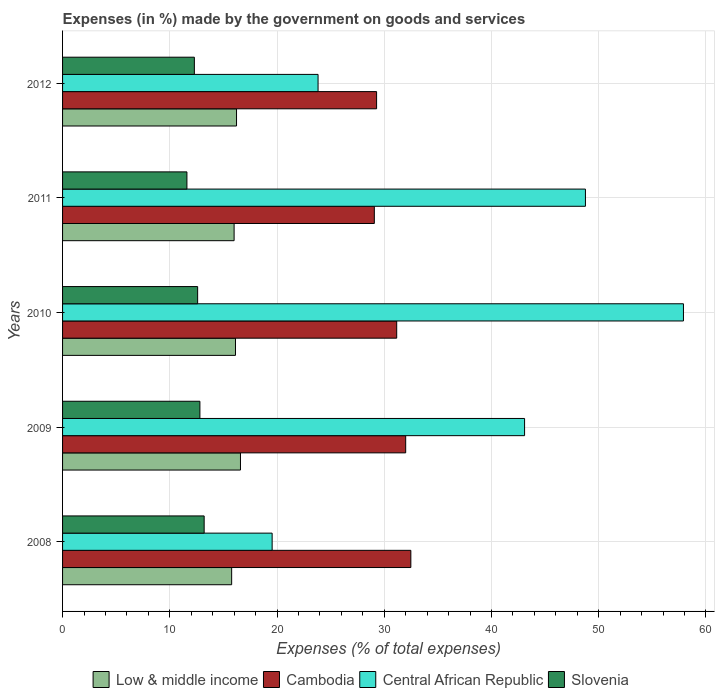How many groups of bars are there?
Offer a terse response. 5. Are the number of bars per tick equal to the number of legend labels?
Your answer should be compact. Yes. Are the number of bars on each tick of the Y-axis equal?
Your answer should be very brief. Yes. How many bars are there on the 4th tick from the top?
Keep it short and to the point. 4. What is the percentage of expenses made by the government on goods and services in Cambodia in 2008?
Give a very brief answer. 32.48. Across all years, what is the maximum percentage of expenses made by the government on goods and services in Cambodia?
Offer a terse response. 32.48. Across all years, what is the minimum percentage of expenses made by the government on goods and services in Low & middle income?
Provide a succinct answer. 15.77. In which year was the percentage of expenses made by the government on goods and services in Low & middle income minimum?
Your response must be concise. 2008. What is the total percentage of expenses made by the government on goods and services in Central African Republic in the graph?
Offer a very short reply. 193.13. What is the difference between the percentage of expenses made by the government on goods and services in Central African Republic in 2010 and that in 2011?
Offer a very short reply. 9.14. What is the difference between the percentage of expenses made by the government on goods and services in Central African Republic in 2011 and the percentage of expenses made by the government on goods and services in Slovenia in 2012?
Keep it short and to the point. 36.47. What is the average percentage of expenses made by the government on goods and services in Cambodia per year?
Your answer should be very brief. 30.8. In the year 2011, what is the difference between the percentage of expenses made by the government on goods and services in Cambodia and percentage of expenses made by the government on goods and services in Slovenia?
Offer a terse response. 17.48. In how many years, is the percentage of expenses made by the government on goods and services in Slovenia greater than 8 %?
Your answer should be compact. 5. What is the ratio of the percentage of expenses made by the government on goods and services in Cambodia in 2009 to that in 2011?
Provide a short and direct response. 1.1. Is the percentage of expenses made by the government on goods and services in Low & middle income in 2008 less than that in 2011?
Offer a terse response. Yes. What is the difference between the highest and the second highest percentage of expenses made by the government on goods and services in Central African Republic?
Offer a very short reply. 9.14. What is the difference between the highest and the lowest percentage of expenses made by the government on goods and services in Central African Republic?
Provide a succinct answer. 38.36. Is it the case that in every year, the sum of the percentage of expenses made by the government on goods and services in Slovenia and percentage of expenses made by the government on goods and services in Cambodia is greater than the sum of percentage of expenses made by the government on goods and services in Central African Republic and percentage of expenses made by the government on goods and services in Low & middle income?
Your response must be concise. Yes. What does the 1st bar from the top in 2012 represents?
Offer a very short reply. Slovenia. What does the 4th bar from the bottom in 2012 represents?
Your answer should be compact. Slovenia. Is it the case that in every year, the sum of the percentage of expenses made by the government on goods and services in Low & middle income and percentage of expenses made by the government on goods and services in Slovenia is greater than the percentage of expenses made by the government on goods and services in Cambodia?
Your response must be concise. No. What is the difference between two consecutive major ticks on the X-axis?
Your response must be concise. 10. Are the values on the major ticks of X-axis written in scientific E-notation?
Give a very brief answer. No. Where does the legend appear in the graph?
Keep it short and to the point. Bottom center. How many legend labels are there?
Provide a succinct answer. 4. What is the title of the graph?
Your answer should be very brief. Expenses (in %) made by the government on goods and services. Does "Greenland" appear as one of the legend labels in the graph?
Offer a very short reply. No. What is the label or title of the X-axis?
Keep it short and to the point. Expenses (% of total expenses). What is the label or title of the Y-axis?
Provide a short and direct response. Years. What is the Expenses (% of total expenses) in Low & middle income in 2008?
Your answer should be compact. 15.77. What is the Expenses (% of total expenses) in Cambodia in 2008?
Keep it short and to the point. 32.48. What is the Expenses (% of total expenses) of Central African Republic in 2008?
Keep it short and to the point. 19.55. What is the Expenses (% of total expenses) in Slovenia in 2008?
Your answer should be very brief. 13.21. What is the Expenses (% of total expenses) in Low & middle income in 2009?
Provide a short and direct response. 16.59. What is the Expenses (% of total expenses) in Cambodia in 2009?
Give a very brief answer. 32. What is the Expenses (% of total expenses) of Central African Republic in 2009?
Your response must be concise. 43.09. What is the Expenses (% of total expenses) in Slovenia in 2009?
Provide a succinct answer. 12.81. What is the Expenses (% of total expenses) of Low & middle income in 2010?
Your answer should be compact. 16.13. What is the Expenses (% of total expenses) in Cambodia in 2010?
Offer a very short reply. 31.16. What is the Expenses (% of total expenses) of Central African Republic in 2010?
Provide a succinct answer. 57.91. What is the Expenses (% of total expenses) of Slovenia in 2010?
Your response must be concise. 12.6. What is the Expenses (% of total expenses) of Low & middle income in 2011?
Make the answer very short. 16. What is the Expenses (% of total expenses) in Cambodia in 2011?
Provide a short and direct response. 29.08. What is the Expenses (% of total expenses) in Central African Republic in 2011?
Provide a short and direct response. 48.76. What is the Expenses (% of total expenses) in Slovenia in 2011?
Provide a succinct answer. 11.6. What is the Expenses (% of total expenses) in Low & middle income in 2012?
Your answer should be very brief. 16.22. What is the Expenses (% of total expenses) in Cambodia in 2012?
Offer a terse response. 29.29. What is the Expenses (% of total expenses) of Central African Republic in 2012?
Offer a very short reply. 23.83. What is the Expenses (% of total expenses) of Slovenia in 2012?
Offer a terse response. 12.29. Across all years, what is the maximum Expenses (% of total expenses) of Low & middle income?
Provide a succinct answer. 16.59. Across all years, what is the maximum Expenses (% of total expenses) in Cambodia?
Your answer should be very brief. 32.48. Across all years, what is the maximum Expenses (% of total expenses) in Central African Republic?
Your answer should be compact. 57.91. Across all years, what is the maximum Expenses (% of total expenses) of Slovenia?
Your answer should be compact. 13.21. Across all years, what is the minimum Expenses (% of total expenses) in Low & middle income?
Keep it short and to the point. 15.77. Across all years, what is the minimum Expenses (% of total expenses) in Cambodia?
Keep it short and to the point. 29.08. Across all years, what is the minimum Expenses (% of total expenses) of Central African Republic?
Make the answer very short. 19.55. Across all years, what is the minimum Expenses (% of total expenses) of Slovenia?
Make the answer very short. 11.6. What is the total Expenses (% of total expenses) in Low & middle income in the graph?
Provide a succinct answer. 80.71. What is the total Expenses (% of total expenses) of Cambodia in the graph?
Your answer should be very brief. 154.01. What is the total Expenses (% of total expenses) in Central African Republic in the graph?
Provide a succinct answer. 193.13. What is the total Expenses (% of total expenses) in Slovenia in the graph?
Keep it short and to the point. 62.5. What is the difference between the Expenses (% of total expenses) of Low & middle income in 2008 and that in 2009?
Keep it short and to the point. -0.82. What is the difference between the Expenses (% of total expenses) in Cambodia in 2008 and that in 2009?
Make the answer very short. 0.48. What is the difference between the Expenses (% of total expenses) of Central African Republic in 2008 and that in 2009?
Your answer should be compact. -23.54. What is the difference between the Expenses (% of total expenses) of Slovenia in 2008 and that in 2009?
Offer a terse response. 0.4. What is the difference between the Expenses (% of total expenses) in Low & middle income in 2008 and that in 2010?
Offer a very short reply. -0.36. What is the difference between the Expenses (% of total expenses) of Cambodia in 2008 and that in 2010?
Keep it short and to the point. 1.32. What is the difference between the Expenses (% of total expenses) in Central African Republic in 2008 and that in 2010?
Provide a short and direct response. -38.36. What is the difference between the Expenses (% of total expenses) of Slovenia in 2008 and that in 2010?
Your answer should be very brief. 0.61. What is the difference between the Expenses (% of total expenses) of Low & middle income in 2008 and that in 2011?
Offer a terse response. -0.23. What is the difference between the Expenses (% of total expenses) in Cambodia in 2008 and that in 2011?
Provide a short and direct response. 3.41. What is the difference between the Expenses (% of total expenses) of Central African Republic in 2008 and that in 2011?
Ensure brevity in your answer.  -29.22. What is the difference between the Expenses (% of total expenses) in Slovenia in 2008 and that in 2011?
Give a very brief answer. 1.61. What is the difference between the Expenses (% of total expenses) in Low & middle income in 2008 and that in 2012?
Ensure brevity in your answer.  -0.45. What is the difference between the Expenses (% of total expenses) in Cambodia in 2008 and that in 2012?
Give a very brief answer. 3.2. What is the difference between the Expenses (% of total expenses) in Central African Republic in 2008 and that in 2012?
Offer a terse response. -4.28. What is the difference between the Expenses (% of total expenses) in Slovenia in 2008 and that in 2012?
Offer a very short reply. 0.91. What is the difference between the Expenses (% of total expenses) of Low & middle income in 2009 and that in 2010?
Give a very brief answer. 0.46. What is the difference between the Expenses (% of total expenses) of Cambodia in 2009 and that in 2010?
Offer a terse response. 0.84. What is the difference between the Expenses (% of total expenses) in Central African Republic in 2009 and that in 2010?
Your answer should be very brief. -14.82. What is the difference between the Expenses (% of total expenses) in Slovenia in 2009 and that in 2010?
Make the answer very short. 0.21. What is the difference between the Expenses (% of total expenses) in Low & middle income in 2009 and that in 2011?
Your answer should be compact. 0.59. What is the difference between the Expenses (% of total expenses) of Cambodia in 2009 and that in 2011?
Your answer should be very brief. 2.92. What is the difference between the Expenses (% of total expenses) in Central African Republic in 2009 and that in 2011?
Your response must be concise. -5.68. What is the difference between the Expenses (% of total expenses) in Slovenia in 2009 and that in 2011?
Make the answer very short. 1.21. What is the difference between the Expenses (% of total expenses) of Low & middle income in 2009 and that in 2012?
Your response must be concise. 0.37. What is the difference between the Expenses (% of total expenses) of Cambodia in 2009 and that in 2012?
Keep it short and to the point. 2.71. What is the difference between the Expenses (% of total expenses) in Central African Republic in 2009 and that in 2012?
Offer a very short reply. 19.26. What is the difference between the Expenses (% of total expenses) of Slovenia in 2009 and that in 2012?
Your answer should be compact. 0.52. What is the difference between the Expenses (% of total expenses) in Low & middle income in 2010 and that in 2011?
Offer a very short reply. 0.13. What is the difference between the Expenses (% of total expenses) in Cambodia in 2010 and that in 2011?
Keep it short and to the point. 2.09. What is the difference between the Expenses (% of total expenses) of Central African Republic in 2010 and that in 2011?
Give a very brief answer. 9.14. What is the difference between the Expenses (% of total expenses) of Low & middle income in 2010 and that in 2012?
Provide a short and direct response. -0.1. What is the difference between the Expenses (% of total expenses) of Cambodia in 2010 and that in 2012?
Provide a short and direct response. 1.88. What is the difference between the Expenses (% of total expenses) in Central African Republic in 2010 and that in 2012?
Give a very brief answer. 34.08. What is the difference between the Expenses (% of total expenses) in Slovenia in 2010 and that in 2012?
Offer a very short reply. 0.31. What is the difference between the Expenses (% of total expenses) in Low & middle income in 2011 and that in 2012?
Your answer should be compact. -0.23. What is the difference between the Expenses (% of total expenses) of Cambodia in 2011 and that in 2012?
Offer a very short reply. -0.21. What is the difference between the Expenses (% of total expenses) in Central African Republic in 2011 and that in 2012?
Your response must be concise. 24.94. What is the difference between the Expenses (% of total expenses) in Slovenia in 2011 and that in 2012?
Your answer should be compact. -0.69. What is the difference between the Expenses (% of total expenses) of Low & middle income in 2008 and the Expenses (% of total expenses) of Cambodia in 2009?
Offer a very short reply. -16.23. What is the difference between the Expenses (% of total expenses) of Low & middle income in 2008 and the Expenses (% of total expenses) of Central African Republic in 2009?
Keep it short and to the point. -27.32. What is the difference between the Expenses (% of total expenses) in Low & middle income in 2008 and the Expenses (% of total expenses) in Slovenia in 2009?
Give a very brief answer. 2.96. What is the difference between the Expenses (% of total expenses) in Cambodia in 2008 and the Expenses (% of total expenses) in Central African Republic in 2009?
Offer a very short reply. -10.61. What is the difference between the Expenses (% of total expenses) of Cambodia in 2008 and the Expenses (% of total expenses) of Slovenia in 2009?
Give a very brief answer. 19.67. What is the difference between the Expenses (% of total expenses) of Central African Republic in 2008 and the Expenses (% of total expenses) of Slovenia in 2009?
Give a very brief answer. 6.74. What is the difference between the Expenses (% of total expenses) of Low & middle income in 2008 and the Expenses (% of total expenses) of Cambodia in 2010?
Keep it short and to the point. -15.39. What is the difference between the Expenses (% of total expenses) in Low & middle income in 2008 and the Expenses (% of total expenses) in Central African Republic in 2010?
Make the answer very short. -42.14. What is the difference between the Expenses (% of total expenses) in Low & middle income in 2008 and the Expenses (% of total expenses) in Slovenia in 2010?
Your response must be concise. 3.17. What is the difference between the Expenses (% of total expenses) of Cambodia in 2008 and the Expenses (% of total expenses) of Central African Republic in 2010?
Keep it short and to the point. -25.42. What is the difference between the Expenses (% of total expenses) in Cambodia in 2008 and the Expenses (% of total expenses) in Slovenia in 2010?
Make the answer very short. 19.88. What is the difference between the Expenses (% of total expenses) of Central African Republic in 2008 and the Expenses (% of total expenses) of Slovenia in 2010?
Provide a short and direct response. 6.95. What is the difference between the Expenses (% of total expenses) of Low & middle income in 2008 and the Expenses (% of total expenses) of Cambodia in 2011?
Make the answer very short. -13.31. What is the difference between the Expenses (% of total expenses) in Low & middle income in 2008 and the Expenses (% of total expenses) in Central African Republic in 2011?
Provide a short and direct response. -32.99. What is the difference between the Expenses (% of total expenses) of Low & middle income in 2008 and the Expenses (% of total expenses) of Slovenia in 2011?
Your answer should be compact. 4.17. What is the difference between the Expenses (% of total expenses) in Cambodia in 2008 and the Expenses (% of total expenses) in Central African Republic in 2011?
Your answer should be very brief. -16.28. What is the difference between the Expenses (% of total expenses) in Cambodia in 2008 and the Expenses (% of total expenses) in Slovenia in 2011?
Your answer should be compact. 20.88. What is the difference between the Expenses (% of total expenses) in Central African Republic in 2008 and the Expenses (% of total expenses) in Slovenia in 2011?
Provide a short and direct response. 7.95. What is the difference between the Expenses (% of total expenses) in Low & middle income in 2008 and the Expenses (% of total expenses) in Cambodia in 2012?
Your answer should be compact. -13.52. What is the difference between the Expenses (% of total expenses) in Low & middle income in 2008 and the Expenses (% of total expenses) in Central African Republic in 2012?
Give a very brief answer. -8.06. What is the difference between the Expenses (% of total expenses) in Low & middle income in 2008 and the Expenses (% of total expenses) in Slovenia in 2012?
Offer a terse response. 3.48. What is the difference between the Expenses (% of total expenses) of Cambodia in 2008 and the Expenses (% of total expenses) of Central African Republic in 2012?
Offer a very short reply. 8.65. What is the difference between the Expenses (% of total expenses) of Cambodia in 2008 and the Expenses (% of total expenses) of Slovenia in 2012?
Make the answer very short. 20.19. What is the difference between the Expenses (% of total expenses) of Central African Republic in 2008 and the Expenses (% of total expenses) of Slovenia in 2012?
Provide a succinct answer. 7.25. What is the difference between the Expenses (% of total expenses) of Low & middle income in 2009 and the Expenses (% of total expenses) of Cambodia in 2010?
Offer a very short reply. -14.57. What is the difference between the Expenses (% of total expenses) in Low & middle income in 2009 and the Expenses (% of total expenses) in Central African Republic in 2010?
Your answer should be very brief. -41.31. What is the difference between the Expenses (% of total expenses) of Low & middle income in 2009 and the Expenses (% of total expenses) of Slovenia in 2010?
Your answer should be compact. 3.99. What is the difference between the Expenses (% of total expenses) in Cambodia in 2009 and the Expenses (% of total expenses) in Central African Republic in 2010?
Make the answer very short. -25.9. What is the difference between the Expenses (% of total expenses) of Cambodia in 2009 and the Expenses (% of total expenses) of Slovenia in 2010?
Make the answer very short. 19.4. What is the difference between the Expenses (% of total expenses) of Central African Republic in 2009 and the Expenses (% of total expenses) of Slovenia in 2010?
Offer a very short reply. 30.49. What is the difference between the Expenses (% of total expenses) of Low & middle income in 2009 and the Expenses (% of total expenses) of Cambodia in 2011?
Your answer should be very brief. -12.49. What is the difference between the Expenses (% of total expenses) in Low & middle income in 2009 and the Expenses (% of total expenses) in Central African Republic in 2011?
Your answer should be compact. -32.17. What is the difference between the Expenses (% of total expenses) of Low & middle income in 2009 and the Expenses (% of total expenses) of Slovenia in 2011?
Offer a terse response. 4.99. What is the difference between the Expenses (% of total expenses) of Cambodia in 2009 and the Expenses (% of total expenses) of Central African Republic in 2011?
Provide a succinct answer. -16.76. What is the difference between the Expenses (% of total expenses) in Cambodia in 2009 and the Expenses (% of total expenses) in Slovenia in 2011?
Provide a short and direct response. 20.4. What is the difference between the Expenses (% of total expenses) of Central African Republic in 2009 and the Expenses (% of total expenses) of Slovenia in 2011?
Keep it short and to the point. 31.49. What is the difference between the Expenses (% of total expenses) of Low & middle income in 2009 and the Expenses (% of total expenses) of Cambodia in 2012?
Ensure brevity in your answer.  -12.7. What is the difference between the Expenses (% of total expenses) of Low & middle income in 2009 and the Expenses (% of total expenses) of Central African Republic in 2012?
Offer a terse response. -7.24. What is the difference between the Expenses (% of total expenses) in Low & middle income in 2009 and the Expenses (% of total expenses) in Slovenia in 2012?
Make the answer very short. 4.3. What is the difference between the Expenses (% of total expenses) of Cambodia in 2009 and the Expenses (% of total expenses) of Central African Republic in 2012?
Your answer should be compact. 8.17. What is the difference between the Expenses (% of total expenses) in Cambodia in 2009 and the Expenses (% of total expenses) in Slovenia in 2012?
Ensure brevity in your answer.  19.71. What is the difference between the Expenses (% of total expenses) of Central African Republic in 2009 and the Expenses (% of total expenses) of Slovenia in 2012?
Keep it short and to the point. 30.8. What is the difference between the Expenses (% of total expenses) of Low & middle income in 2010 and the Expenses (% of total expenses) of Cambodia in 2011?
Offer a terse response. -12.95. What is the difference between the Expenses (% of total expenses) of Low & middle income in 2010 and the Expenses (% of total expenses) of Central African Republic in 2011?
Ensure brevity in your answer.  -32.64. What is the difference between the Expenses (% of total expenses) of Low & middle income in 2010 and the Expenses (% of total expenses) of Slovenia in 2011?
Keep it short and to the point. 4.53. What is the difference between the Expenses (% of total expenses) in Cambodia in 2010 and the Expenses (% of total expenses) in Central African Republic in 2011?
Offer a terse response. -17.6. What is the difference between the Expenses (% of total expenses) of Cambodia in 2010 and the Expenses (% of total expenses) of Slovenia in 2011?
Give a very brief answer. 19.57. What is the difference between the Expenses (% of total expenses) in Central African Republic in 2010 and the Expenses (% of total expenses) in Slovenia in 2011?
Your response must be concise. 46.31. What is the difference between the Expenses (% of total expenses) of Low & middle income in 2010 and the Expenses (% of total expenses) of Cambodia in 2012?
Give a very brief answer. -13.16. What is the difference between the Expenses (% of total expenses) of Low & middle income in 2010 and the Expenses (% of total expenses) of Central African Republic in 2012?
Ensure brevity in your answer.  -7.7. What is the difference between the Expenses (% of total expenses) of Low & middle income in 2010 and the Expenses (% of total expenses) of Slovenia in 2012?
Keep it short and to the point. 3.84. What is the difference between the Expenses (% of total expenses) in Cambodia in 2010 and the Expenses (% of total expenses) in Central African Republic in 2012?
Make the answer very short. 7.33. What is the difference between the Expenses (% of total expenses) in Cambodia in 2010 and the Expenses (% of total expenses) in Slovenia in 2012?
Provide a short and direct response. 18.87. What is the difference between the Expenses (% of total expenses) of Central African Republic in 2010 and the Expenses (% of total expenses) of Slovenia in 2012?
Ensure brevity in your answer.  45.61. What is the difference between the Expenses (% of total expenses) of Low & middle income in 2011 and the Expenses (% of total expenses) of Cambodia in 2012?
Offer a very short reply. -13.29. What is the difference between the Expenses (% of total expenses) of Low & middle income in 2011 and the Expenses (% of total expenses) of Central African Republic in 2012?
Offer a terse response. -7.83. What is the difference between the Expenses (% of total expenses) in Low & middle income in 2011 and the Expenses (% of total expenses) in Slovenia in 2012?
Ensure brevity in your answer.  3.71. What is the difference between the Expenses (% of total expenses) in Cambodia in 2011 and the Expenses (% of total expenses) in Central African Republic in 2012?
Your answer should be compact. 5.25. What is the difference between the Expenses (% of total expenses) of Cambodia in 2011 and the Expenses (% of total expenses) of Slovenia in 2012?
Provide a short and direct response. 16.78. What is the difference between the Expenses (% of total expenses) of Central African Republic in 2011 and the Expenses (% of total expenses) of Slovenia in 2012?
Your answer should be compact. 36.47. What is the average Expenses (% of total expenses) of Low & middle income per year?
Your answer should be compact. 16.14. What is the average Expenses (% of total expenses) of Cambodia per year?
Make the answer very short. 30.8. What is the average Expenses (% of total expenses) of Central African Republic per year?
Provide a short and direct response. 38.63. What is the average Expenses (% of total expenses) in Slovenia per year?
Your answer should be very brief. 12.5. In the year 2008, what is the difference between the Expenses (% of total expenses) of Low & middle income and Expenses (% of total expenses) of Cambodia?
Keep it short and to the point. -16.71. In the year 2008, what is the difference between the Expenses (% of total expenses) of Low & middle income and Expenses (% of total expenses) of Central African Republic?
Your answer should be compact. -3.78. In the year 2008, what is the difference between the Expenses (% of total expenses) in Low & middle income and Expenses (% of total expenses) in Slovenia?
Ensure brevity in your answer.  2.56. In the year 2008, what is the difference between the Expenses (% of total expenses) of Cambodia and Expenses (% of total expenses) of Central African Republic?
Offer a terse response. 12.94. In the year 2008, what is the difference between the Expenses (% of total expenses) of Cambodia and Expenses (% of total expenses) of Slovenia?
Your answer should be very brief. 19.28. In the year 2008, what is the difference between the Expenses (% of total expenses) in Central African Republic and Expenses (% of total expenses) in Slovenia?
Offer a terse response. 6.34. In the year 2009, what is the difference between the Expenses (% of total expenses) in Low & middle income and Expenses (% of total expenses) in Cambodia?
Keep it short and to the point. -15.41. In the year 2009, what is the difference between the Expenses (% of total expenses) of Low & middle income and Expenses (% of total expenses) of Central African Republic?
Offer a very short reply. -26.5. In the year 2009, what is the difference between the Expenses (% of total expenses) of Low & middle income and Expenses (% of total expenses) of Slovenia?
Your answer should be very brief. 3.78. In the year 2009, what is the difference between the Expenses (% of total expenses) in Cambodia and Expenses (% of total expenses) in Central African Republic?
Provide a short and direct response. -11.09. In the year 2009, what is the difference between the Expenses (% of total expenses) of Cambodia and Expenses (% of total expenses) of Slovenia?
Your answer should be very brief. 19.19. In the year 2009, what is the difference between the Expenses (% of total expenses) of Central African Republic and Expenses (% of total expenses) of Slovenia?
Ensure brevity in your answer.  30.28. In the year 2010, what is the difference between the Expenses (% of total expenses) in Low & middle income and Expenses (% of total expenses) in Cambodia?
Make the answer very short. -15.04. In the year 2010, what is the difference between the Expenses (% of total expenses) in Low & middle income and Expenses (% of total expenses) in Central African Republic?
Offer a terse response. -41.78. In the year 2010, what is the difference between the Expenses (% of total expenses) in Low & middle income and Expenses (% of total expenses) in Slovenia?
Your answer should be compact. 3.53. In the year 2010, what is the difference between the Expenses (% of total expenses) of Cambodia and Expenses (% of total expenses) of Central African Republic?
Provide a succinct answer. -26.74. In the year 2010, what is the difference between the Expenses (% of total expenses) in Cambodia and Expenses (% of total expenses) in Slovenia?
Offer a terse response. 18.57. In the year 2010, what is the difference between the Expenses (% of total expenses) in Central African Republic and Expenses (% of total expenses) in Slovenia?
Your response must be concise. 45.31. In the year 2011, what is the difference between the Expenses (% of total expenses) in Low & middle income and Expenses (% of total expenses) in Cambodia?
Ensure brevity in your answer.  -13.08. In the year 2011, what is the difference between the Expenses (% of total expenses) of Low & middle income and Expenses (% of total expenses) of Central African Republic?
Ensure brevity in your answer.  -32.77. In the year 2011, what is the difference between the Expenses (% of total expenses) of Low & middle income and Expenses (% of total expenses) of Slovenia?
Your answer should be compact. 4.4. In the year 2011, what is the difference between the Expenses (% of total expenses) in Cambodia and Expenses (% of total expenses) in Central African Republic?
Give a very brief answer. -19.69. In the year 2011, what is the difference between the Expenses (% of total expenses) of Cambodia and Expenses (% of total expenses) of Slovenia?
Offer a terse response. 17.48. In the year 2011, what is the difference between the Expenses (% of total expenses) in Central African Republic and Expenses (% of total expenses) in Slovenia?
Keep it short and to the point. 37.17. In the year 2012, what is the difference between the Expenses (% of total expenses) in Low & middle income and Expenses (% of total expenses) in Cambodia?
Your response must be concise. -13.06. In the year 2012, what is the difference between the Expenses (% of total expenses) of Low & middle income and Expenses (% of total expenses) of Central African Republic?
Keep it short and to the point. -7.6. In the year 2012, what is the difference between the Expenses (% of total expenses) of Low & middle income and Expenses (% of total expenses) of Slovenia?
Offer a terse response. 3.93. In the year 2012, what is the difference between the Expenses (% of total expenses) in Cambodia and Expenses (% of total expenses) in Central African Republic?
Your answer should be compact. 5.46. In the year 2012, what is the difference between the Expenses (% of total expenses) in Cambodia and Expenses (% of total expenses) in Slovenia?
Your answer should be very brief. 16.99. In the year 2012, what is the difference between the Expenses (% of total expenses) of Central African Republic and Expenses (% of total expenses) of Slovenia?
Your response must be concise. 11.54. What is the ratio of the Expenses (% of total expenses) of Low & middle income in 2008 to that in 2009?
Offer a terse response. 0.95. What is the ratio of the Expenses (% of total expenses) of Cambodia in 2008 to that in 2009?
Offer a terse response. 1.01. What is the ratio of the Expenses (% of total expenses) of Central African Republic in 2008 to that in 2009?
Make the answer very short. 0.45. What is the ratio of the Expenses (% of total expenses) of Slovenia in 2008 to that in 2009?
Your answer should be very brief. 1.03. What is the ratio of the Expenses (% of total expenses) of Low & middle income in 2008 to that in 2010?
Offer a terse response. 0.98. What is the ratio of the Expenses (% of total expenses) of Cambodia in 2008 to that in 2010?
Make the answer very short. 1.04. What is the ratio of the Expenses (% of total expenses) of Central African Republic in 2008 to that in 2010?
Your answer should be very brief. 0.34. What is the ratio of the Expenses (% of total expenses) of Slovenia in 2008 to that in 2010?
Keep it short and to the point. 1.05. What is the ratio of the Expenses (% of total expenses) of Low & middle income in 2008 to that in 2011?
Make the answer very short. 0.99. What is the ratio of the Expenses (% of total expenses) in Cambodia in 2008 to that in 2011?
Your answer should be very brief. 1.12. What is the ratio of the Expenses (% of total expenses) in Central African Republic in 2008 to that in 2011?
Your response must be concise. 0.4. What is the ratio of the Expenses (% of total expenses) in Slovenia in 2008 to that in 2011?
Make the answer very short. 1.14. What is the ratio of the Expenses (% of total expenses) of Cambodia in 2008 to that in 2012?
Give a very brief answer. 1.11. What is the ratio of the Expenses (% of total expenses) of Central African Republic in 2008 to that in 2012?
Your answer should be very brief. 0.82. What is the ratio of the Expenses (% of total expenses) of Slovenia in 2008 to that in 2012?
Provide a succinct answer. 1.07. What is the ratio of the Expenses (% of total expenses) of Low & middle income in 2009 to that in 2010?
Your response must be concise. 1.03. What is the ratio of the Expenses (% of total expenses) of Cambodia in 2009 to that in 2010?
Ensure brevity in your answer.  1.03. What is the ratio of the Expenses (% of total expenses) in Central African Republic in 2009 to that in 2010?
Provide a succinct answer. 0.74. What is the ratio of the Expenses (% of total expenses) in Slovenia in 2009 to that in 2010?
Your response must be concise. 1.02. What is the ratio of the Expenses (% of total expenses) in Low & middle income in 2009 to that in 2011?
Make the answer very short. 1.04. What is the ratio of the Expenses (% of total expenses) of Cambodia in 2009 to that in 2011?
Your answer should be very brief. 1.1. What is the ratio of the Expenses (% of total expenses) of Central African Republic in 2009 to that in 2011?
Give a very brief answer. 0.88. What is the ratio of the Expenses (% of total expenses) in Slovenia in 2009 to that in 2011?
Keep it short and to the point. 1.1. What is the ratio of the Expenses (% of total expenses) of Low & middle income in 2009 to that in 2012?
Your response must be concise. 1.02. What is the ratio of the Expenses (% of total expenses) of Cambodia in 2009 to that in 2012?
Ensure brevity in your answer.  1.09. What is the ratio of the Expenses (% of total expenses) of Central African Republic in 2009 to that in 2012?
Your answer should be very brief. 1.81. What is the ratio of the Expenses (% of total expenses) in Slovenia in 2009 to that in 2012?
Give a very brief answer. 1.04. What is the ratio of the Expenses (% of total expenses) in Low & middle income in 2010 to that in 2011?
Make the answer very short. 1.01. What is the ratio of the Expenses (% of total expenses) of Cambodia in 2010 to that in 2011?
Provide a short and direct response. 1.07. What is the ratio of the Expenses (% of total expenses) in Central African Republic in 2010 to that in 2011?
Offer a very short reply. 1.19. What is the ratio of the Expenses (% of total expenses) in Slovenia in 2010 to that in 2011?
Give a very brief answer. 1.09. What is the ratio of the Expenses (% of total expenses) in Low & middle income in 2010 to that in 2012?
Your answer should be very brief. 0.99. What is the ratio of the Expenses (% of total expenses) of Cambodia in 2010 to that in 2012?
Give a very brief answer. 1.06. What is the ratio of the Expenses (% of total expenses) in Central African Republic in 2010 to that in 2012?
Your response must be concise. 2.43. What is the ratio of the Expenses (% of total expenses) in Slovenia in 2010 to that in 2012?
Keep it short and to the point. 1.02. What is the ratio of the Expenses (% of total expenses) in Low & middle income in 2011 to that in 2012?
Your answer should be very brief. 0.99. What is the ratio of the Expenses (% of total expenses) of Cambodia in 2011 to that in 2012?
Provide a short and direct response. 0.99. What is the ratio of the Expenses (% of total expenses) in Central African Republic in 2011 to that in 2012?
Ensure brevity in your answer.  2.05. What is the ratio of the Expenses (% of total expenses) of Slovenia in 2011 to that in 2012?
Make the answer very short. 0.94. What is the difference between the highest and the second highest Expenses (% of total expenses) of Low & middle income?
Make the answer very short. 0.37. What is the difference between the highest and the second highest Expenses (% of total expenses) in Cambodia?
Ensure brevity in your answer.  0.48. What is the difference between the highest and the second highest Expenses (% of total expenses) of Central African Republic?
Offer a very short reply. 9.14. What is the difference between the highest and the second highest Expenses (% of total expenses) of Slovenia?
Provide a short and direct response. 0.4. What is the difference between the highest and the lowest Expenses (% of total expenses) of Low & middle income?
Make the answer very short. 0.82. What is the difference between the highest and the lowest Expenses (% of total expenses) in Cambodia?
Provide a succinct answer. 3.41. What is the difference between the highest and the lowest Expenses (% of total expenses) in Central African Republic?
Provide a short and direct response. 38.36. What is the difference between the highest and the lowest Expenses (% of total expenses) of Slovenia?
Ensure brevity in your answer.  1.61. 